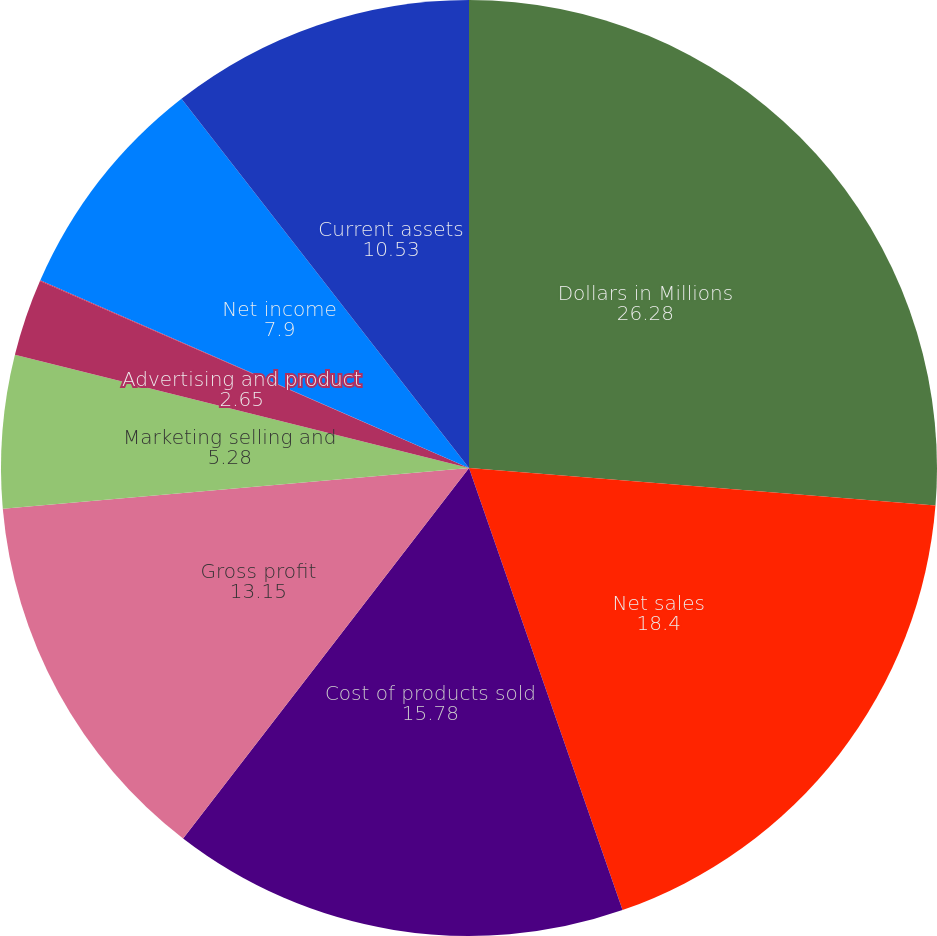Convert chart to OTSL. <chart><loc_0><loc_0><loc_500><loc_500><pie_chart><fcel>Dollars in Millions<fcel>Net sales<fcel>Cost of products sold<fcel>Gross profit<fcel>Marketing selling and<fcel>Advertising and product<fcel>Research and development<fcel>Net income<fcel>Current assets<nl><fcel>26.28%<fcel>18.4%<fcel>15.78%<fcel>13.15%<fcel>5.28%<fcel>2.65%<fcel>0.03%<fcel>7.9%<fcel>10.53%<nl></chart> 